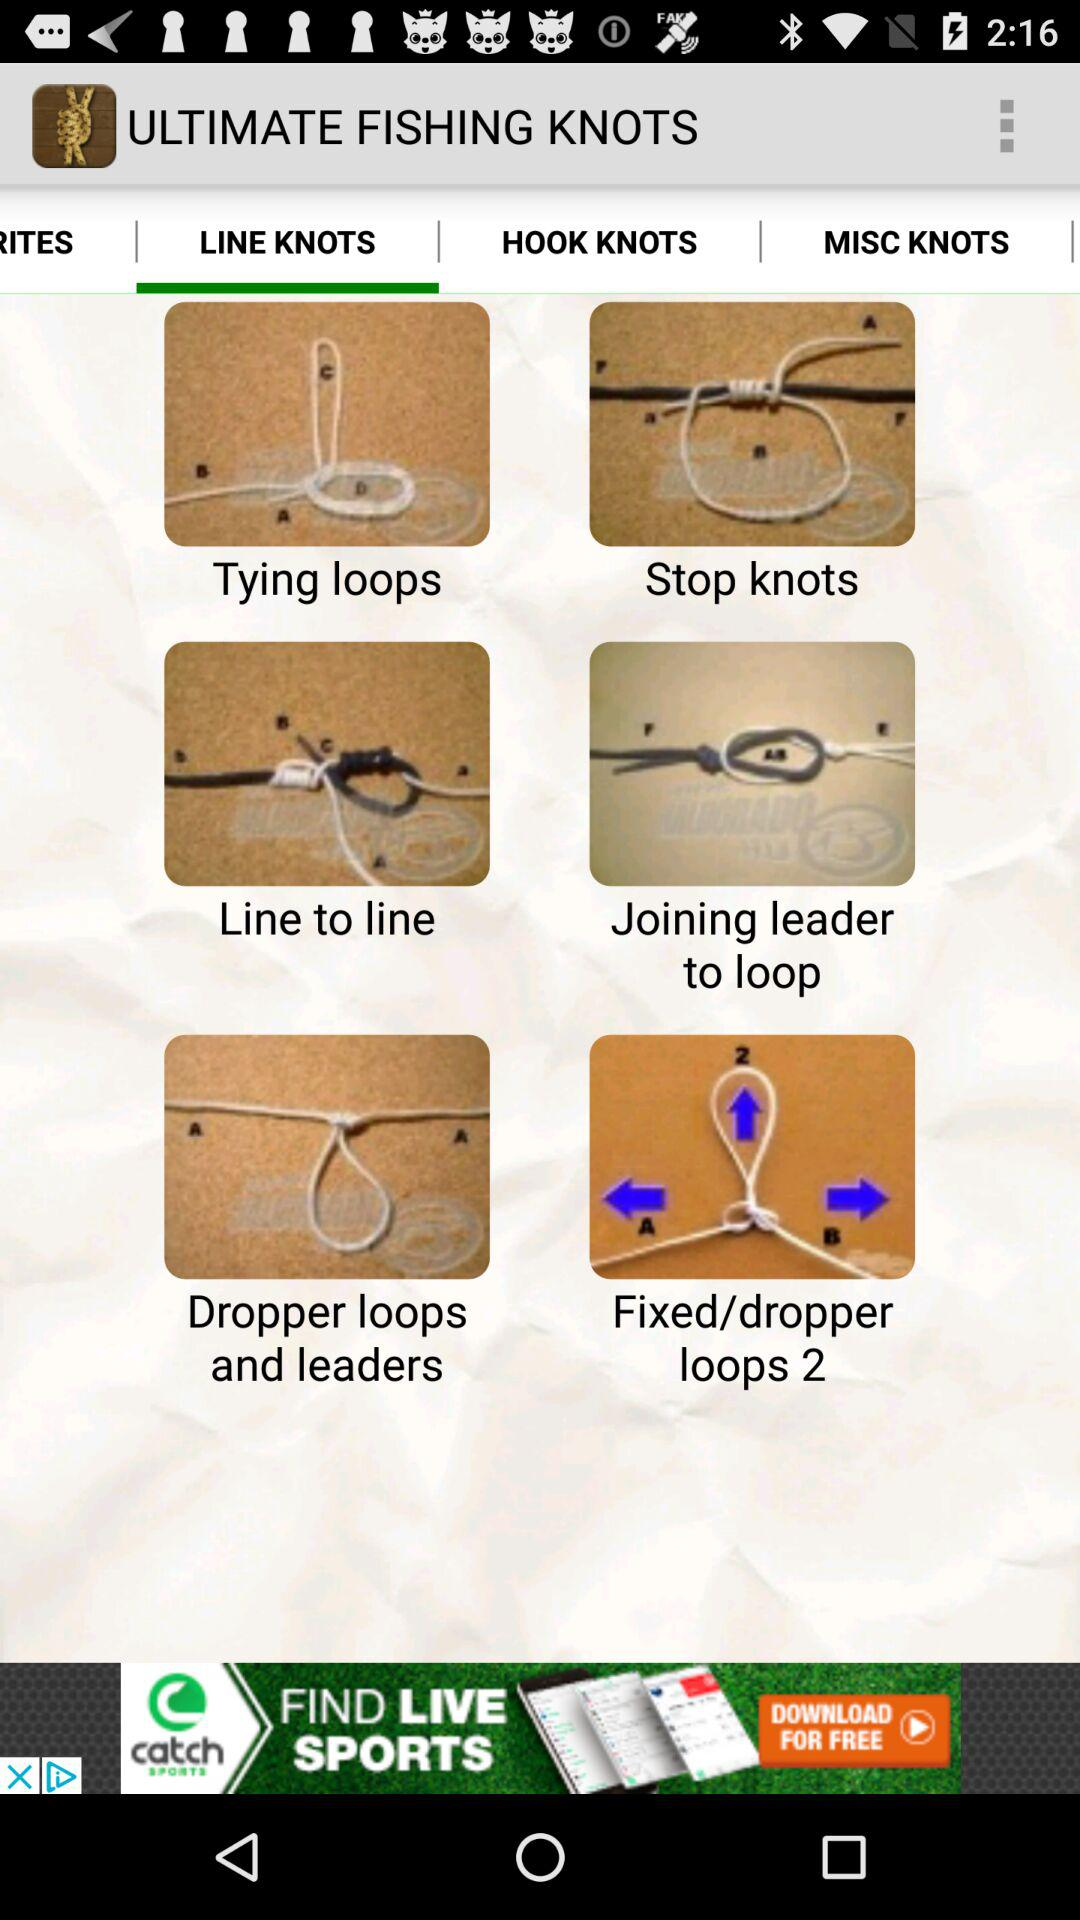Which tab is selected? The selected tab is "LINE KNOTS". 